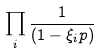Convert formula to latex. <formula><loc_0><loc_0><loc_500><loc_500>\prod _ { i } \frac { 1 } { ( 1 - \xi _ { i } p ) }</formula> 